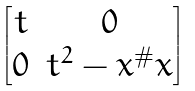<formula> <loc_0><loc_0><loc_500><loc_500>\begin{bmatrix} t & 0 \\ 0 & t ^ { 2 } - x ^ { \# } x \end{bmatrix}</formula> 